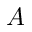Convert formula to latex. <formula><loc_0><loc_0><loc_500><loc_500>A</formula> 